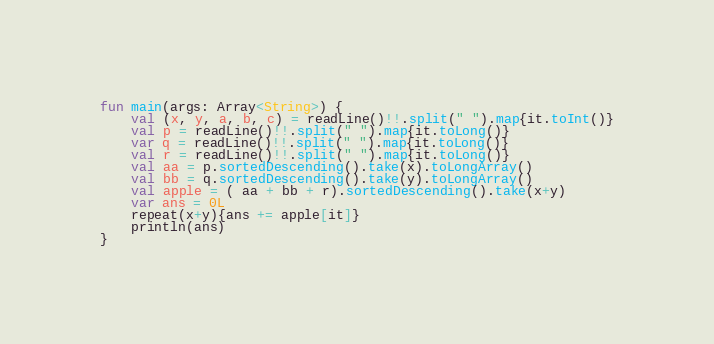<code> <loc_0><loc_0><loc_500><loc_500><_Kotlin_>fun main(args: Array<String>) {
    val (x, y, a, b, c) = readLine()!!.split(" ").map{it.toInt()}
    val p = readLine()!!.split(" ").map{it.toLong()}
    var q = readLine()!!.split(" ").map{it.toLong()}
    val r = readLine()!!.split(" ").map{it.toLong()}
    val aa = p.sortedDescending().take(x).toLongArray()
    val bb = q.sortedDescending().take(y).toLongArray()
    val apple = ( aa + bb + r).sortedDescending().take(x+y)
    var ans = 0L
    repeat(x+y){ans += apple[it]}
    println(ans)
}
</code> 